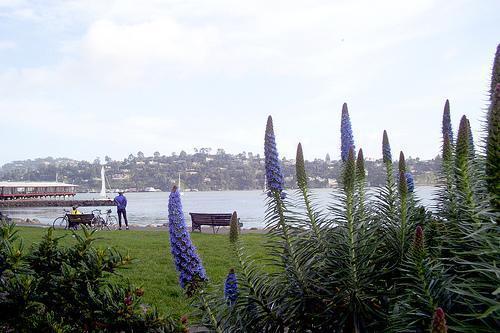How many benches in front of the water?
Give a very brief answer. 2. 